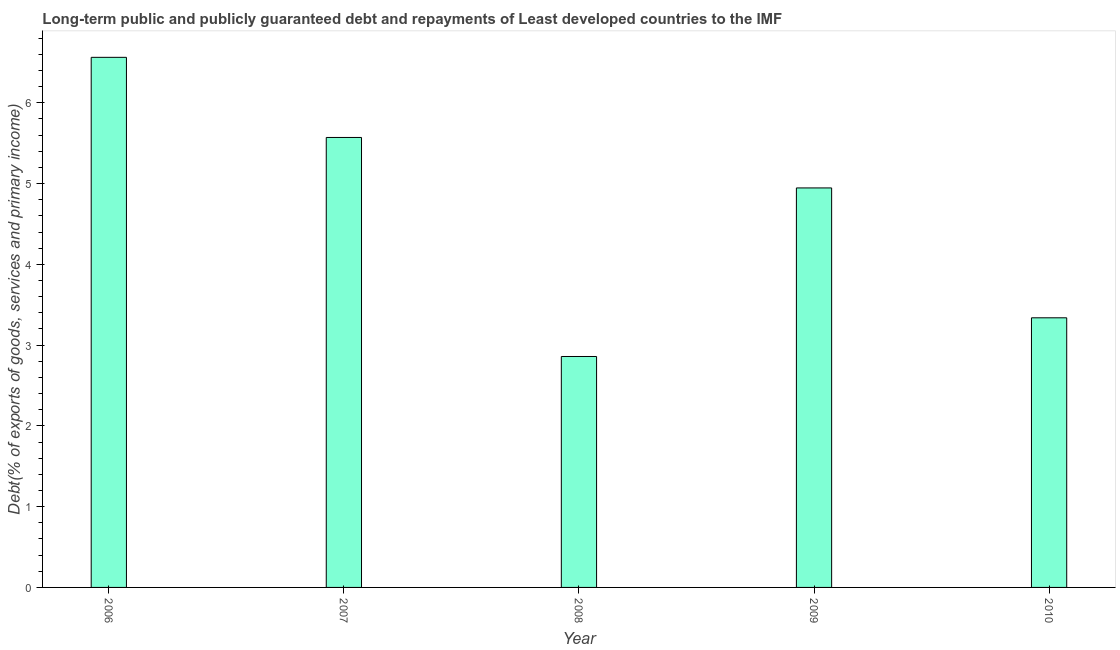Does the graph contain any zero values?
Provide a succinct answer. No. Does the graph contain grids?
Your answer should be compact. No. What is the title of the graph?
Give a very brief answer. Long-term public and publicly guaranteed debt and repayments of Least developed countries to the IMF. What is the label or title of the Y-axis?
Make the answer very short. Debt(% of exports of goods, services and primary income). What is the debt service in 2008?
Ensure brevity in your answer.  2.86. Across all years, what is the maximum debt service?
Offer a terse response. 6.56. Across all years, what is the minimum debt service?
Keep it short and to the point. 2.86. In which year was the debt service maximum?
Your answer should be very brief. 2006. What is the sum of the debt service?
Your response must be concise. 23.28. What is the difference between the debt service in 2008 and 2010?
Provide a succinct answer. -0.48. What is the average debt service per year?
Provide a succinct answer. 4.66. What is the median debt service?
Give a very brief answer. 4.95. In how many years, is the debt service greater than 3.2 %?
Give a very brief answer. 4. What is the ratio of the debt service in 2006 to that in 2008?
Provide a succinct answer. 2.29. Is the debt service in 2007 less than that in 2009?
Offer a very short reply. No. Is the difference between the debt service in 2006 and 2009 greater than the difference between any two years?
Offer a very short reply. No. What is the difference between the highest and the second highest debt service?
Give a very brief answer. 0.99. Is the sum of the debt service in 2008 and 2009 greater than the maximum debt service across all years?
Ensure brevity in your answer.  Yes. What is the difference between the highest and the lowest debt service?
Keep it short and to the point. 3.7. In how many years, is the debt service greater than the average debt service taken over all years?
Provide a succinct answer. 3. Are all the bars in the graph horizontal?
Give a very brief answer. No. How many years are there in the graph?
Provide a succinct answer. 5. What is the difference between two consecutive major ticks on the Y-axis?
Make the answer very short. 1. What is the Debt(% of exports of goods, services and primary income) of 2006?
Your answer should be compact. 6.56. What is the Debt(% of exports of goods, services and primary income) of 2007?
Keep it short and to the point. 5.57. What is the Debt(% of exports of goods, services and primary income) in 2008?
Provide a succinct answer. 2.86. What is the Debt(% of exports of goods, services and primary income) of 2009?
Provide a short and direct response. 4.95. What is the Debt(% of exports of goods, services and primary income) of 2010?
Give a very brief answer. 3.34. What is the difference between the Debt(% of exports of goods, services and primary income) in 2006 and 2007?
Offer a very short reply. 0.99. What is the difference between the Debt(% of exports of goods, services and primary income) in 2006 and 2008?
Ensure brevity in your answer.  3.7. What is the difference between the Debt(% of exports of goods, services and primary income) in 2006 and 2009?
Provide a short and direct response. 1.62. What is the difference between the Debt(% of exports of goods, services and primary income) in 2006 and 2010?
Your answer should be very brief. 3.22. What is the difference between the Debt(% of exports of goods, services and primary income) in 2007 and 2008?
Your answer should be compact. 2.71. What is the difference between the Debt(% of exports of goods, services and primary income) in 2007 and 2009?
Your answer should be compact. 0.62. What is the difference between the Debt(% of exports of goods, services and primary income) in 2007 and 2010?
Provide a short and direct response. 2.23. What is the difference between the Debt(% of exports of goods, services and primary income) in 2008 and 2009?
Your answer should be compact. -2.09. What is the difference between the Debt(% of exports of goods, services and primary income) in 2008 and 2010?
Offer a very short reply. -0.48. What is the difference between the Debt(% of exports of goods, services and primary income) in 2009 and 2010?
Provide a succinct answer. 1.61. What is the ratio of the Debt(% of exports of goods, services and primary income) in 2006 to that in 2007?
Keep it short and to the point. 1.18. What is the ratio of the Debt(% of exports of goods, services and primary income) in 2006 to that in 2008?
Ensure brevity in your answer.  2.29. What is the ratio of the Debt(% of exports of goods, services and primary income) in 2006 to that in 2009?
Offer a terse response. 1.33. What is the ratio of the Debt(% of exports of goods, services and primary income) in 2006 to that in 2010?
Make the answer very short. 1.97. What is the ratio of the Debt(% of exports of goods, services and primary income) in 2007 to that in 2008?
Ensure brevity in your answer.  1.95. What is the ratio of the Debt(% of exports of goods, services and primary income) in 2007 to that in 2009?
Your answer should be very brief. 1.13. What is the ratio of the Debt(% of exports of goods, services and primary income) in 2007 to that in 2010?
Provide a succinct answer. 1.67. What is the ratio of the Debt(% of exports of goods, services and primary income) in 2008 to that in 2009?
Keep it short and to the point. 0.58. What is the ratio of the Debt(% of exports of goods, services and primary income) in 2008 to that in 2010?
Provide a succinct answer. 0.86. What is the ratio of the Debt(% of exports of goods, services and primary income) in 2009 to that in 2010?
Your response must be concise. 1.48. 